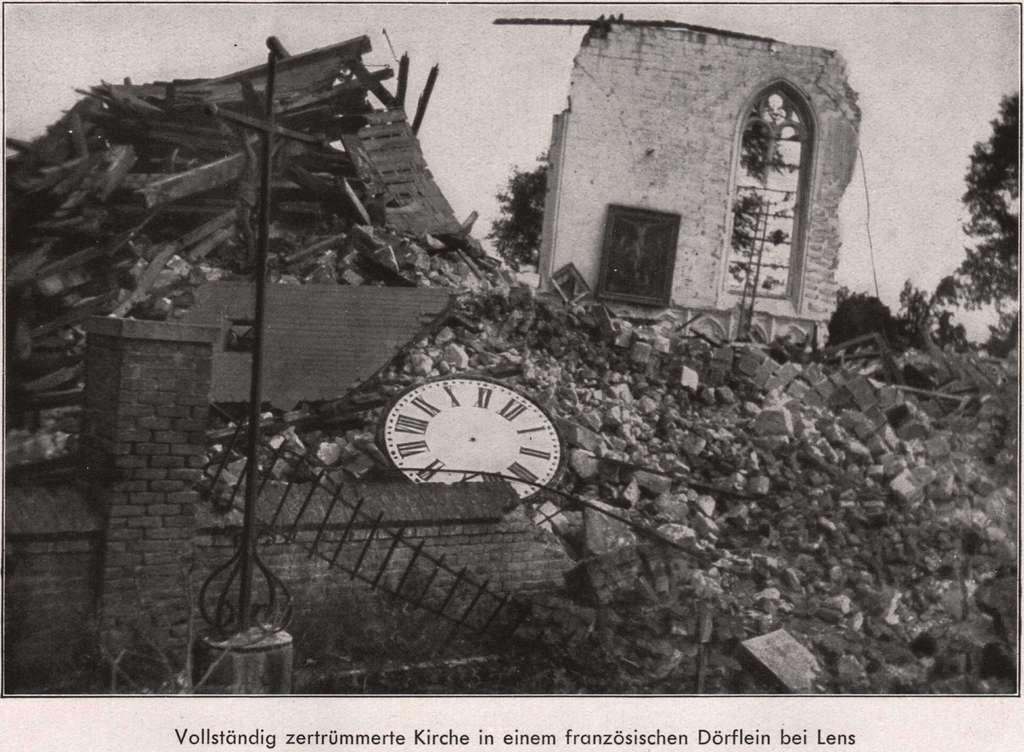<image>
Write a terse but informative summary of the picture. A destroyed building with a german caption Vollstandig. 